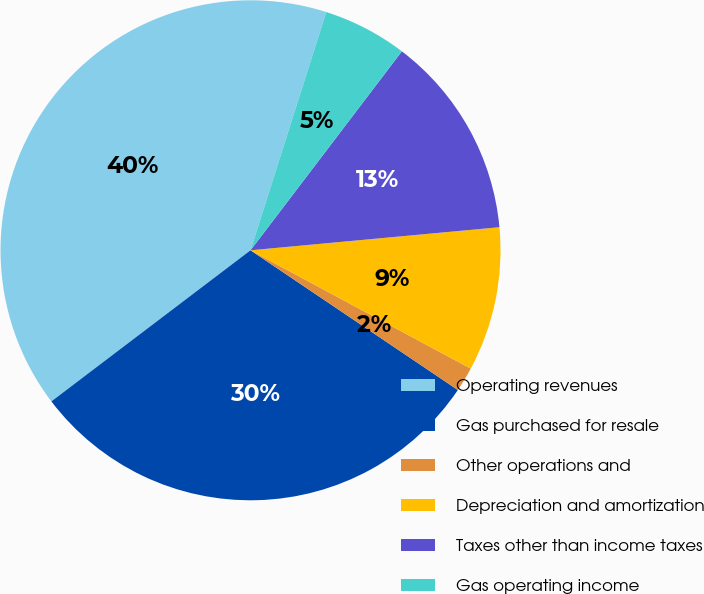Convert chart. <chart><loc_0><loc_0><loc_500><loc_500><pie_chart><fcel>Operating revenues<fcel>Gas purchased for resale<fcel>Other operations and<fcel>Depreciation and amortization<fcel>Taxes other than income taxes<fcel>Gas operating income<nl><fcel>40.23%<fcel>30.23%<fcel>1.59%<fcel>9.32%<fcel>13.18%<fcel>5.45%<nl></chart> 